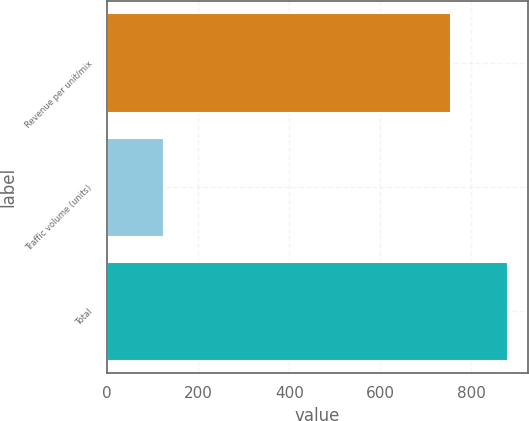Convert chart. <chart><loc_0><loc_0><loc_500><loc_500><bar_chart><fcel>Revenue per unit/mix<fcel>Traffic volume (units)<fcel>Total<nl><fcel>755<fcel>125<fcel>880<nl></chart> 